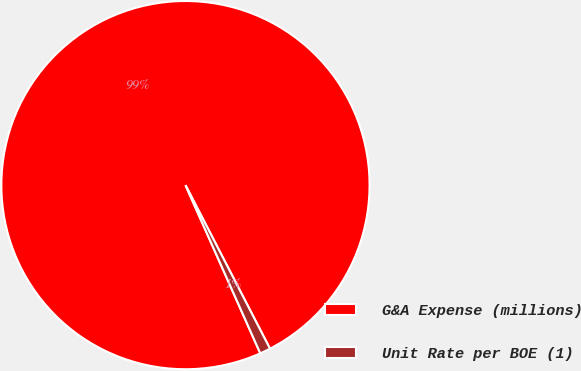Convert chart to OTSL. <chart><loc_0><loc_0><loc_500><loc_500><pie_chart><fcel>G&A Expense (millions)<fcel>Unit Rate per BOE (1)<nl><fcel>99.07%<fcel>0.93%<nl></chart> 